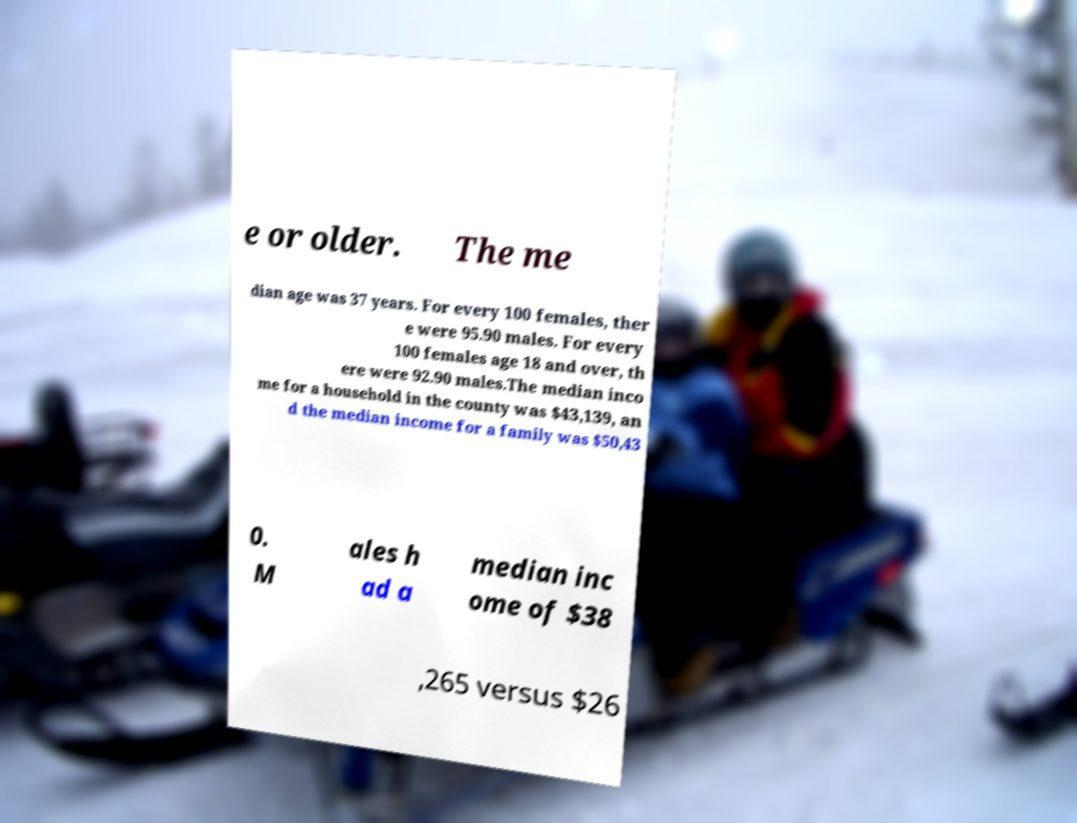What messages or text are displayed in this image? I need them in a readable, typed format. e or older. The me dian age was 37 years. For every 100 females, ther e were 95.90 males. For every 100 females age 18 and over, th ere were 92.90 males.The median inco me for a household in the county was $43,139, an d the median income for a family was $50,43 0. M ales h ad a median inc ome of $38 ,265 versus $26 